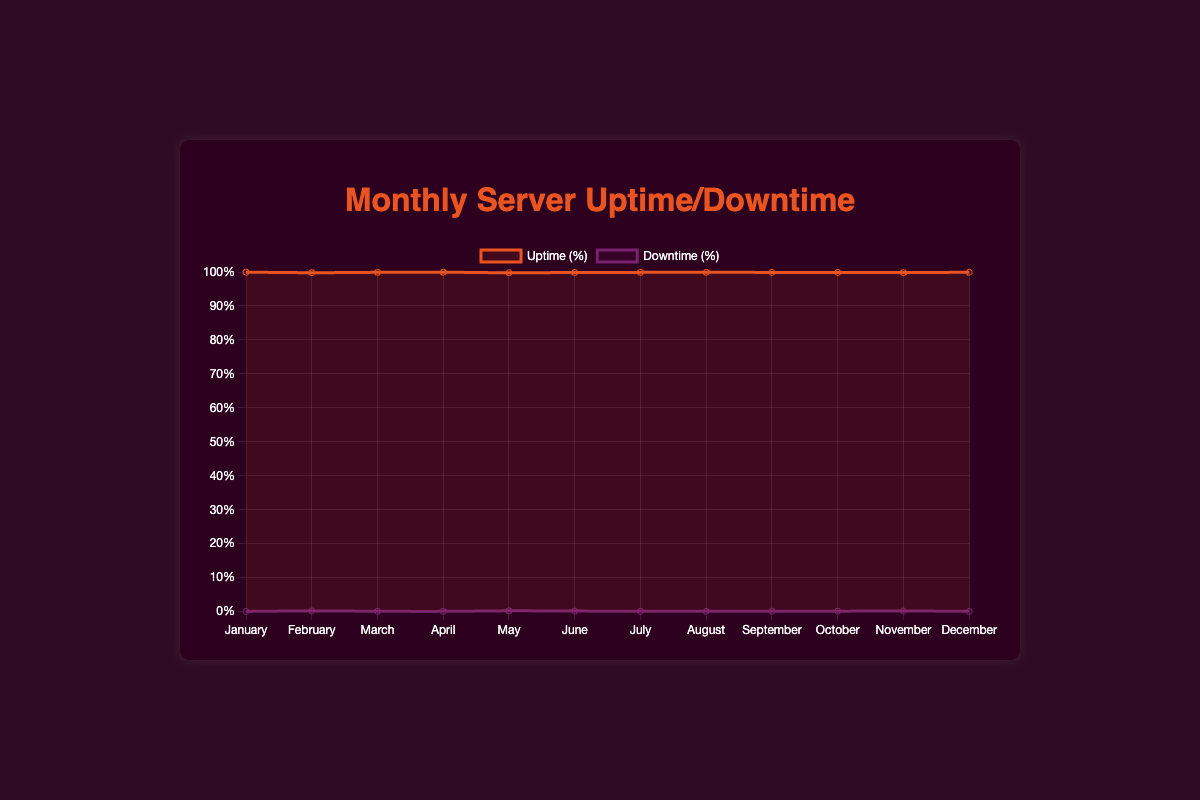Which month had the highest uptime percentage? Observing the line for Uptime (%) on the figure, the highest point on the y-axis corresponding to the months indicates the peak uptime. January and December both have the highest uptime at 99.95%.
Answer: January and December How many months had a downtime percentage of 0.10% or higher? By examining the Downtime (%) line, count the months where the line reaches or exceeds 0.10%. These months are February, March, May, June, July, September, October, and November, totaling 8 months.
Answer: 8 What is the average downtime percentage over the year? Sum the downtime percentages across all months: 0.05 + 0.20 + 0.10 + 0.07 + 0.22 + 0.15 + 0.11 + 0.08 + 0.12 + 0.13 + 0.18 + 0.07 = 1.48. Then, divide by the number of months (12): 1.48 / 12 ≈ 0.12.
Answer: 0.12 Is there any month where the uptime percentage is lower than 99.80%? Checking the Uptime (%) line, look for any month points that fall below 99.80%. The lowest uptime percentage is 99.78% in May.
Answer: May Which month had the largest difference between uptime and downtime percentages? Calculate the difference for each month and determine the maximum: all differences are 99.90, with the largest noticeable one being closest to uptime of 99.78 - 0.22 = 99.56, for May.
Answer: May How does the uptime percentage in July compare to August? Compare directly by referring to the Uptime line: July has 99.89% and August has 99.92%. Thus, the uptime percentage in July is less than August.
Answer: Less than August What was the trend for downtime percentage from January to December? Observing the Downtime (%) line from left (January) to right (December), the fluctuations show an increasing trend till May, then a dip and repeating pattern, ending slightly higher in December.
Answer: Fluctuates and ends higher in December Which month showed the smallest difference between uptime and downtime percentages? Calculate the difference for each month: January has the smallest difference since 99.95 - 0.05 = 99.90.
Answer: January How many months had an uptime percentage of 99.85% or higher? By examining the Uptime (%) line, count the months where the uptime is 99.85% or higher: January, March, April, June, July, August, September, October, and December, totaling 9 months.
Answer: 9 months 